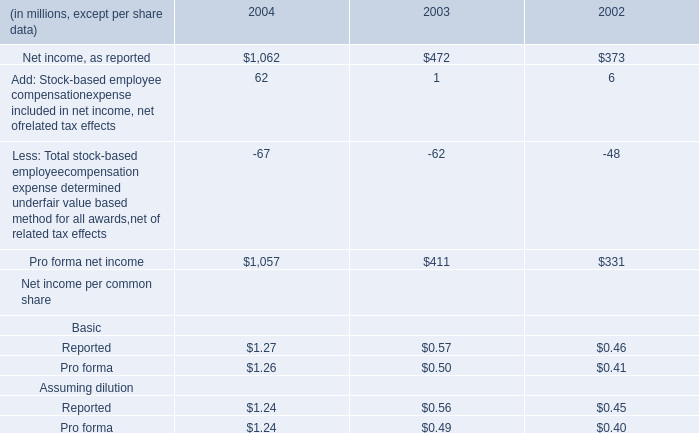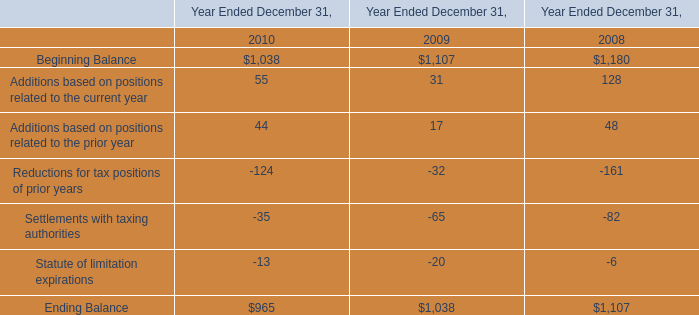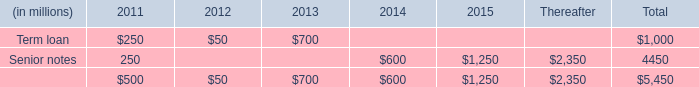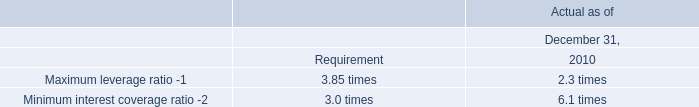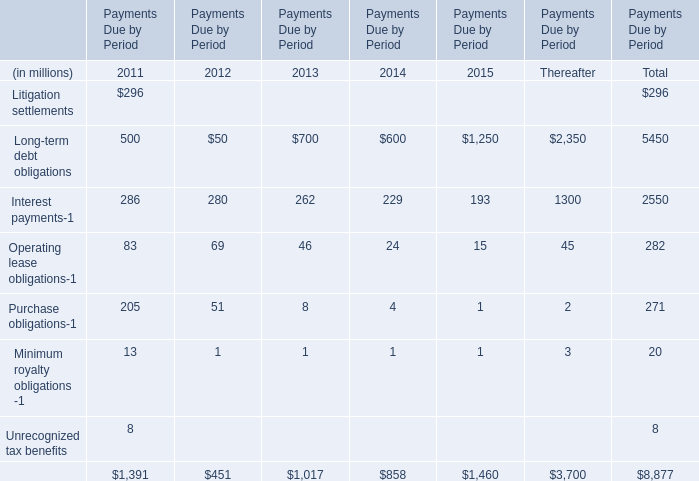What's the 20 % of total elements in 2011? (in million) 
Computations: (1391 * 0.2)
Answer: 278.2. 